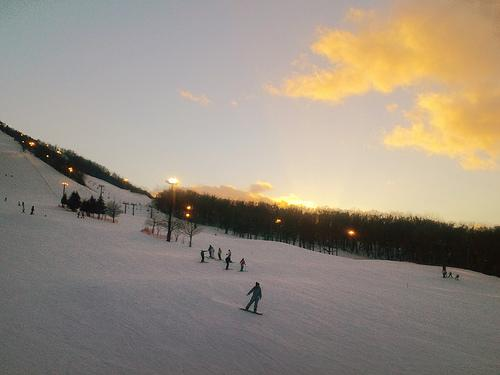Identify all the objects mentioned in the image related to skiing and snowboarding and describe their actions or properties. Objects related to skiing and snowboarding include skiers on the slopes, snow on the ground, down-hill skiers, a snowboarder going down the hill, people in the snow, snowboard on snow, group of skiers on ski slope, and the person snowboarding. They are all engaging in the winter sports, sliding down the snow-covered slopes at varying speeds and positions. What emotions and feelings does the image evoke, and how do the elements in the picture contribute to these emotions? The image evokes a sense of tranquility, adventure, and excitement. The tranquil setting is created by the soft colors of the sky and the snow-covered landscape, while the adventure and excitement come from the people joyfully skiing and snowboarding on the slopes. What is the primary activity happening in the picture and who is participating in it? The primary activity happening in the picture is skiing and snowboarding, participated by a group of people on the snow-covered slopes. What do the sun and clouds contribute to the overall atmosphere of the image? The sun setting and clouds in the sky create a serene and picturesque atmosphere in the image, adding a dramatic effect to the scene. Analyze the texture of the snow in the picture and explain how it contributes to the overall scene. The snow appears white and smooth, covering the ground and creating a contrast with the greenery and people on the slopes, enhancing the overall winter landscape of the scene. In the image, describe the predominant colors and where they appear in relation to each other. The predominant colors in the image are blue in the sky, white on the snow-covered ground, and green in the trees. The blue sky appears above the white snow, while the green trees are set on the slopes amidst the snow. List the two main types of vegetation visible in the image and their characteristics. The two main types of vegetation visible in the image are trees along the slopes and small trees along the ski slope, both appearing green. Identify the main weather feature in the sky and describe its appearance. The main weather feature in the sky is a large cloud, which appears yellow and covers a significant portion of the sky. Describe the lighting conditions on the ski slopes as seen in the image. The lighting conditions on the ski slopes are illuminated by the lights on the ski slopes, which seem to be switched on. Based on the image, describe the incline of the hill and how it impacts the scene and activities. There is a steep part of the hill and a flatter portion of the hill in the image. The incline impacts the scene by providing different levels of challenge for the skiers and snowboarders, as well as contributing to the overall dynamic and diverse landscape of the ski slopes. Look for a cat sitting on top of the snowboarder's head. There is no mention of a cat in the image or any objects related to them. This misleading instruction asks the reader to look for an object that is non-existent, using a declarative sentence. A group of snowmen is chilling out next to the skiers. Check out their funny hats! No, it's not mentioned in the image. Did you find the smiling snowflake mascot standing among the group of skiers? The image captions do not mention any mascots, snowflakes or related objects. This instruction uses an interrogative sentence to ask the reader to locate a non-existent object in the image. Do you notice any flying saucers hovering above the trees in the background? None of the image captions reference flying saucers or anything unusual in the sky. This misleading instruction uses an interrogative sentence to look for an object that is not present in the image. Can you spot the seagull flying between the clouds and the ski slopes? The image captions do not mention any birds or seagulls. This misleading instruction poses an interrogative sentence to find a non-existent object in the image. 